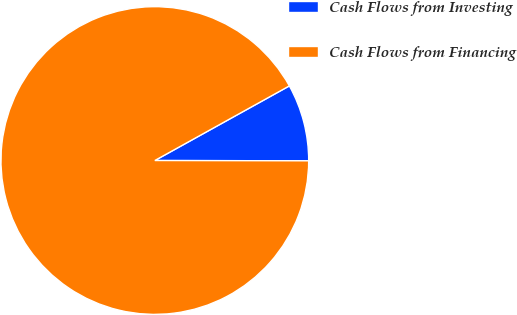Convert chart to OTSL. <chart><loc_0><loc_0><loc_500><loc_500><pie_chart><fcel>Cash Flows from Investing<fcel>Cash Flows from Financing<nl><fcel>8.09%<fcel>91.91%<nl></chart> 